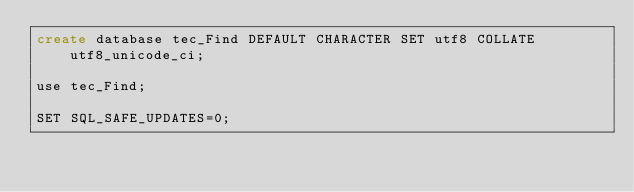Convert code to text. <code><loc_0><loc_0><loc_500><loc_500><_SQL_>create database tec_Find DEFAULT CHARACTER SET utf8 COLLATE utf8_unicode_ci;

use tec_Find;

SET SQL_SAFE_UPDATES=0;


</code> 